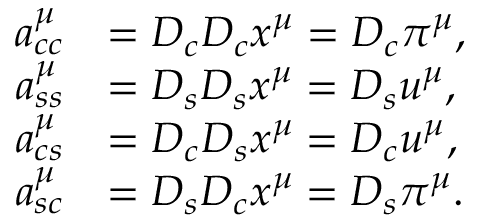<formula> <loc_0><loc_0><loc_500><loc_500>\begin{array} { r l } { a _ { c c } ^ { \mu } } & { = D _ { c } D _ { c } x ^ { \mu } = D _ { c } \pi ^ { \mu } , } \\ { a _ { s s } ^ { \mu } } & { = D _ { s } D _ { s } x ^ { \mu } = D _ { s } u ^ { \mu } , } \\ { a _ { c s } ^ { \mu } } & { = D _ { c } D _ { s } x ^ { \mu } = D _ { c } u ^ { \mu } , } \\ { a _ { s c } ^ { \mu } } & { = D _ { s } D _ { c } x ^ { \mu } = D _ { s } \pi ^ { \mu } . } \end{array}</formula> 